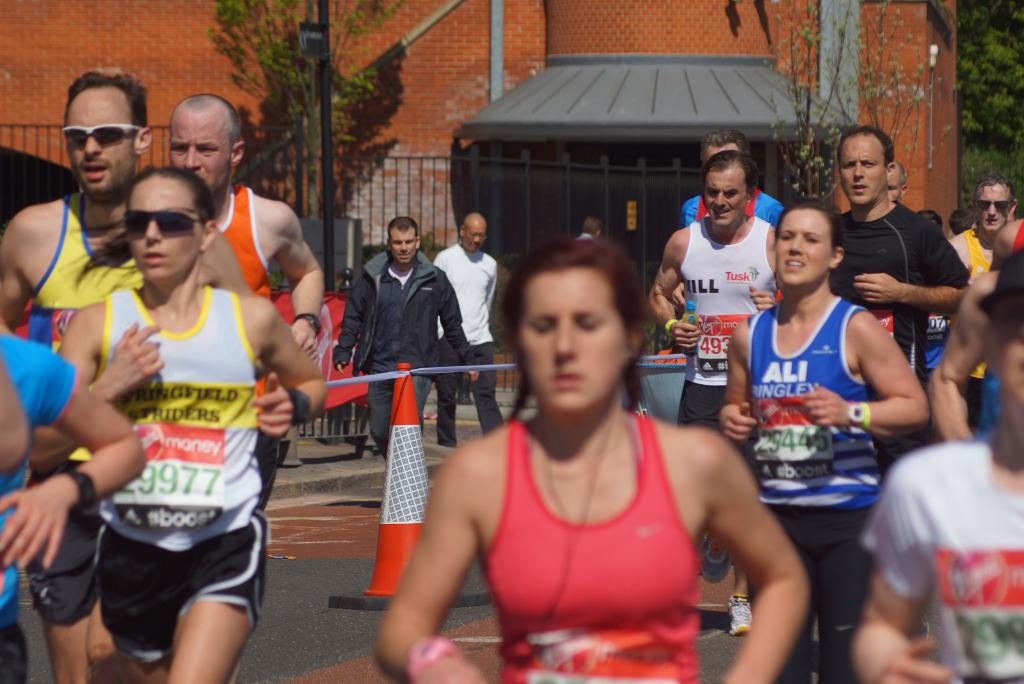How might the weather conditions affect the runners' performance in the race shown in the image? The sunny weather, as depicted in the image, might provide an energetic atmosphere but can also pose challenges like overheating. Runners might need to stay hydrated more frequently and use sun protection to maintain their performance throughout the race. 